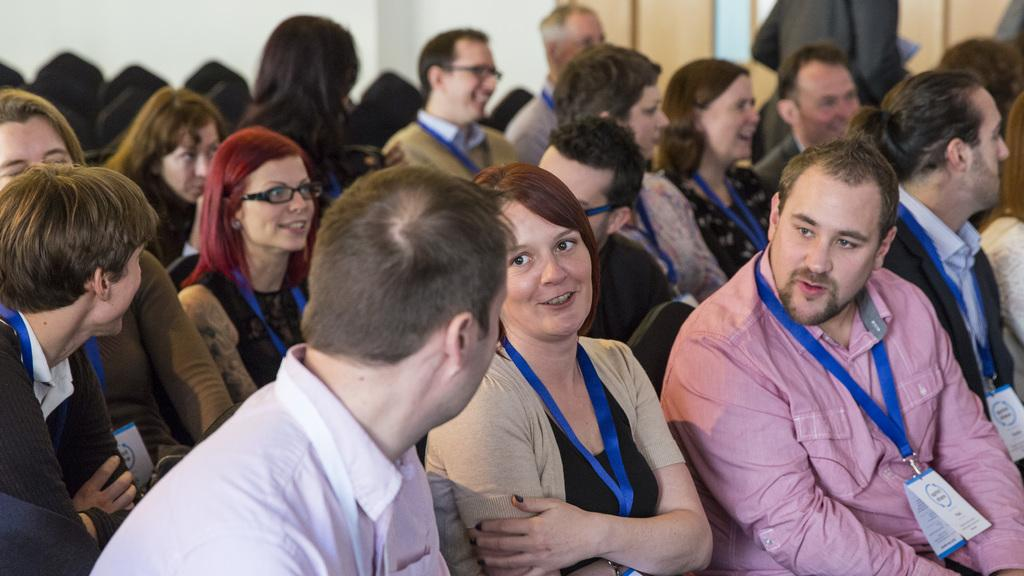Who or what is present in the image? There are people in the image. What are the people doing in the image? The people are sitting on chairs. Can you describe the background of the image? The background of the image is blurred. What hobbies do the people have in the image? There is no information about the people's hobbies in the image. What type of hand can be seen holding a thing in the image? There is no hand or thing present in the image. 